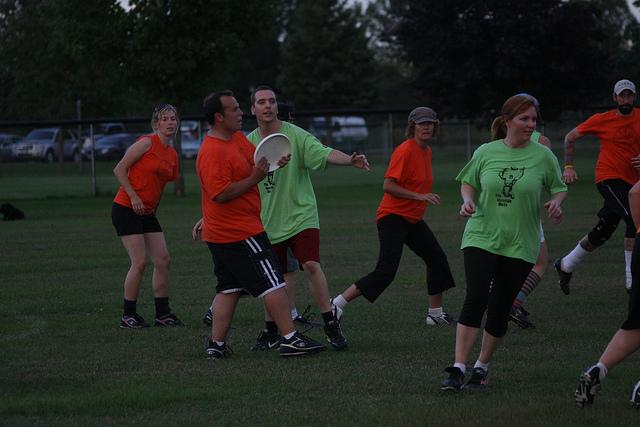What color shirt is the guy to the left wearing?
Write a very short answer. Orange. How many are wearing orange shirts?
Answer briefly. 4. How many players are pictured?
Give a very brief answer. 8. Are these police officers?
Keep it brief. No. Do any of the players have beards?
Concise answer only. No. What are the orange things?
Quick response, please. Shirts. What color are the two teams?
Quick response, please. Green and orange. What is the average age between them?
Give a very brief answer. 25. What sport are they playing?
Short answer required. Frisbee. What sport is being played?
Concise answer only. Frisbee. How many pairs of shoes do you see?
Concise answer only. 8. How many of these people are women?
Concise answer only. 3. What game are they playing?
Be succinct. Frisbee. What is the ethnicity of the woman wearing the green shirt with the black hair?
Keep it brief. White. How many people are wearing hoodies?
Concise answer only. 0. What color is the frisbee?
Short answer required. White. What color is the bus in the background?
Concise answer only. White. Is everyone wearing a shirt?
Be succinct. Yes. 